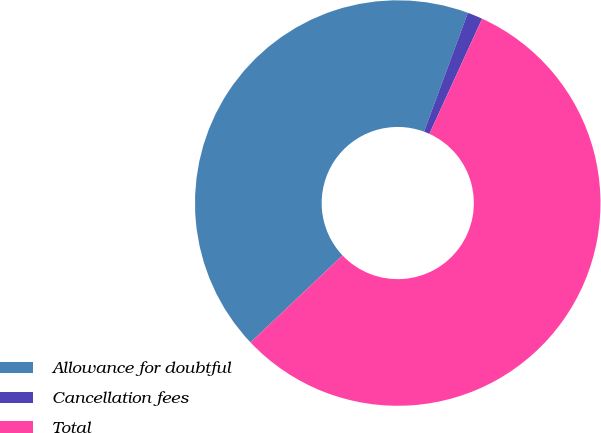<chart> <loc_0><loc_0><loc_500><loc_500><pie_chart><fcel>Allowance for doubtful<fcel>Cancellation fees<fcel>Total<nl><fcel>42.69%<fcel>1.21%<fcel>56.1%<nl></chart> 